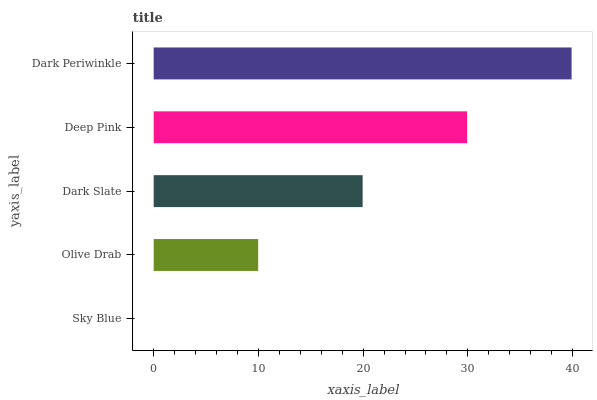Is Sky Blue the minimum?
Answer yes or no. Yes. Is Dark Periwinkle the maximum?
Answer yes or no. Yes. Is Olive Drab the minimum?
Answer yes or no. No. Is Olive Drab the maximum?
Answer yes or no. No. Is Olive Drab greater than Sky Blue?
Answer yes or no. Yes. Is Sky Blue less than Olive Drab?
Answer yes or no. Yes. Is Sky Blue greater than Olive Drab?
Answer yes or no. No. Is Olive Drab less than Sky Blue?
Answer yes or no. No. Is Dark Slate the high median?
Answer yes or no. Yes. Is Dark Slate the low median?
Answer yes or no. Yes. Is Dark Periwinkle the high median?
Answer yes or no. No. Is Olive Drab the low median?
Answer yes or no. No. 